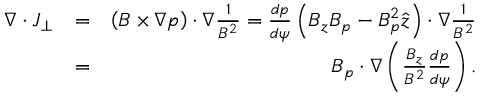<formula> <loc_0><loc_0><loc_500><loc_500>\begin{array} { r l r } { \nabla \cdot J _ { \perp } } & { = } & { \left ( B \times \nabla p \right ) \cdot \nabla \frac { 1 } { B ^ { 2 } } = \frac { d p } { d \psi } \left ( B _ { z } B _ { p } - B _ { p } ^ { 2 } \hat { z } \right ) \cdot \nabla \frac { 1 } { B ^ { 2 } } } \\ & { = } & { B _ { p } \cdot \nabla \left ( \frac { B _ { z } } { B ^ { 2 } } \frac { d p } { d \psi } \right ) . } \end{array}</formula> 